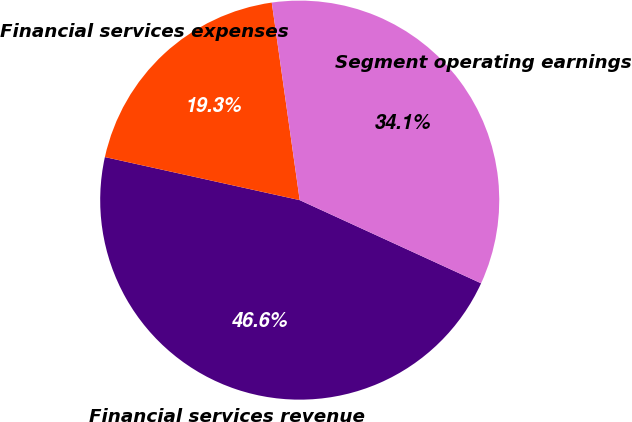<chart> <loc_0><loc_0><loc_500><loc_500><pie_chart><fcel>Financial services revenue<fcel>Financial services expenses<fcel>Segment operating earnings<nl><fcel>46.62%<fcel>19.3%<fcel>34.08%<nl></chart> 